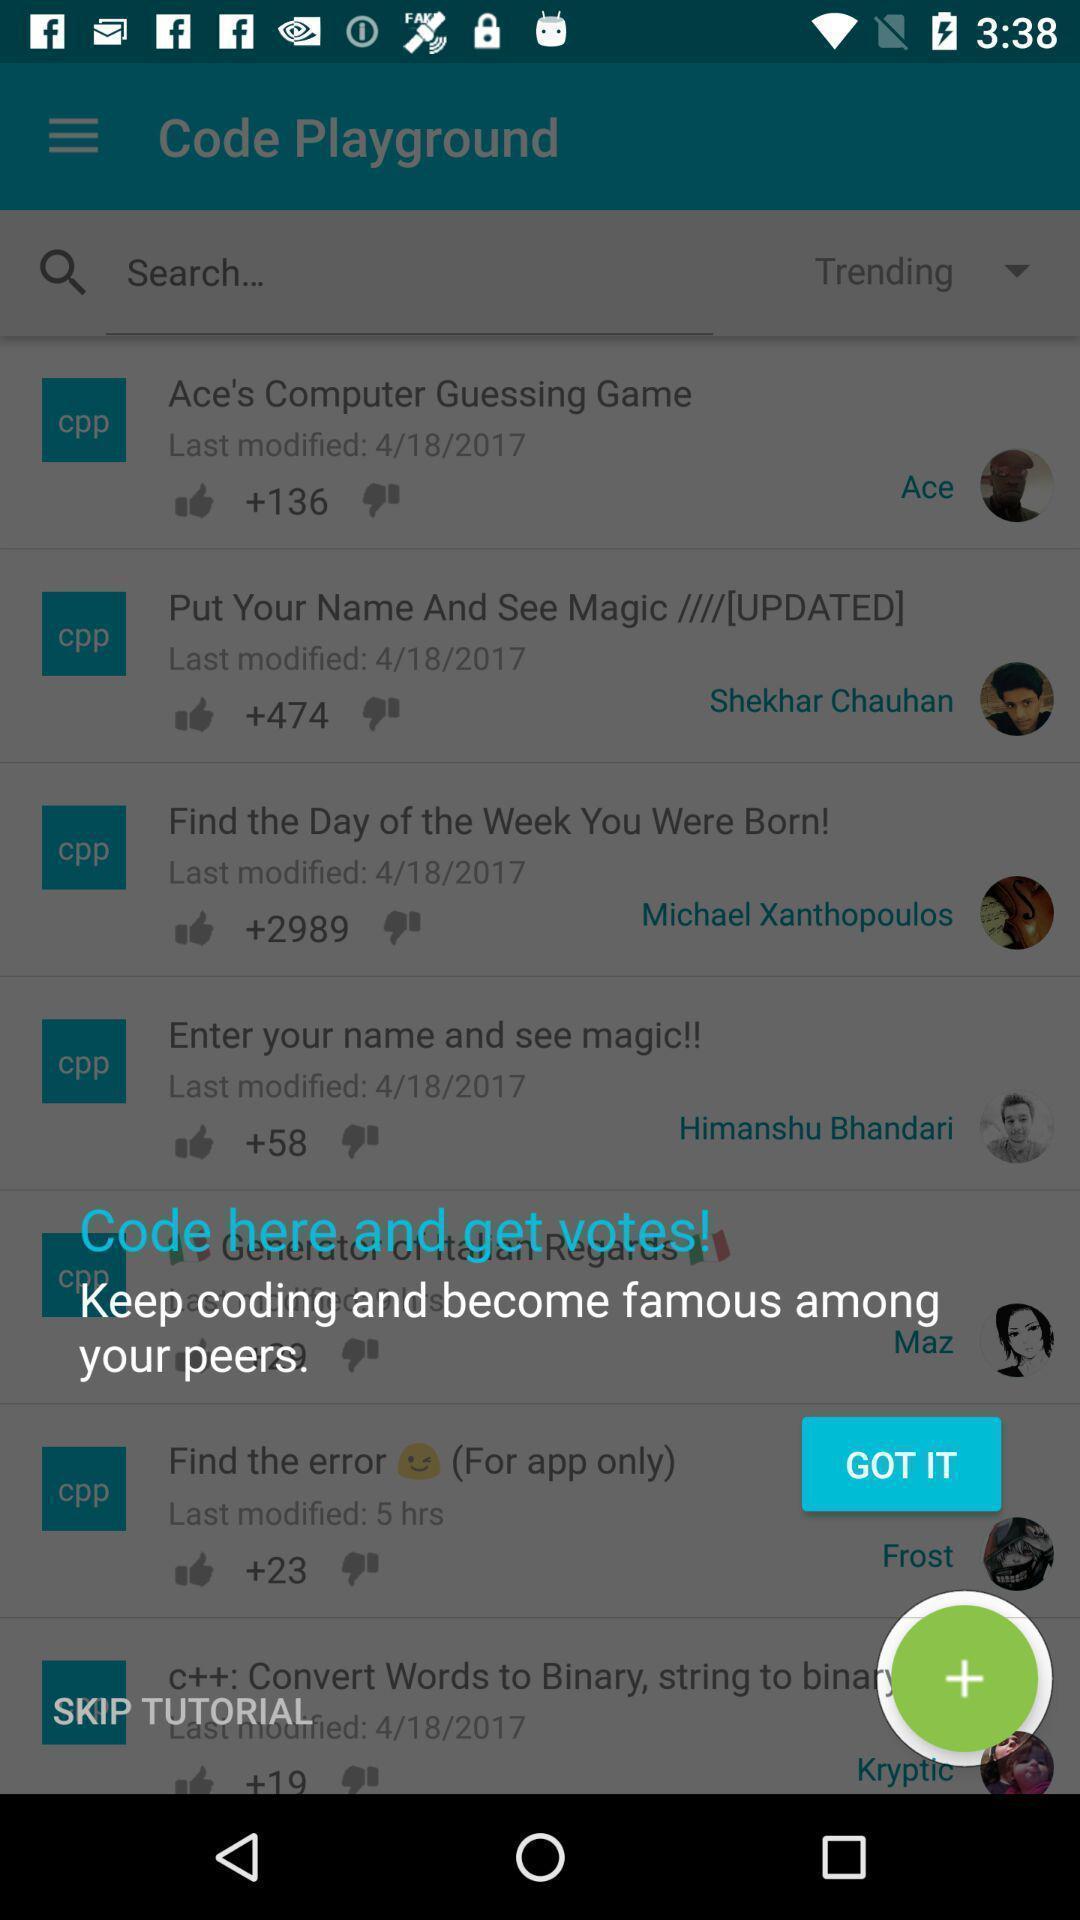Explain what's happening in this screen capture. Pop up to code in a coding app. 